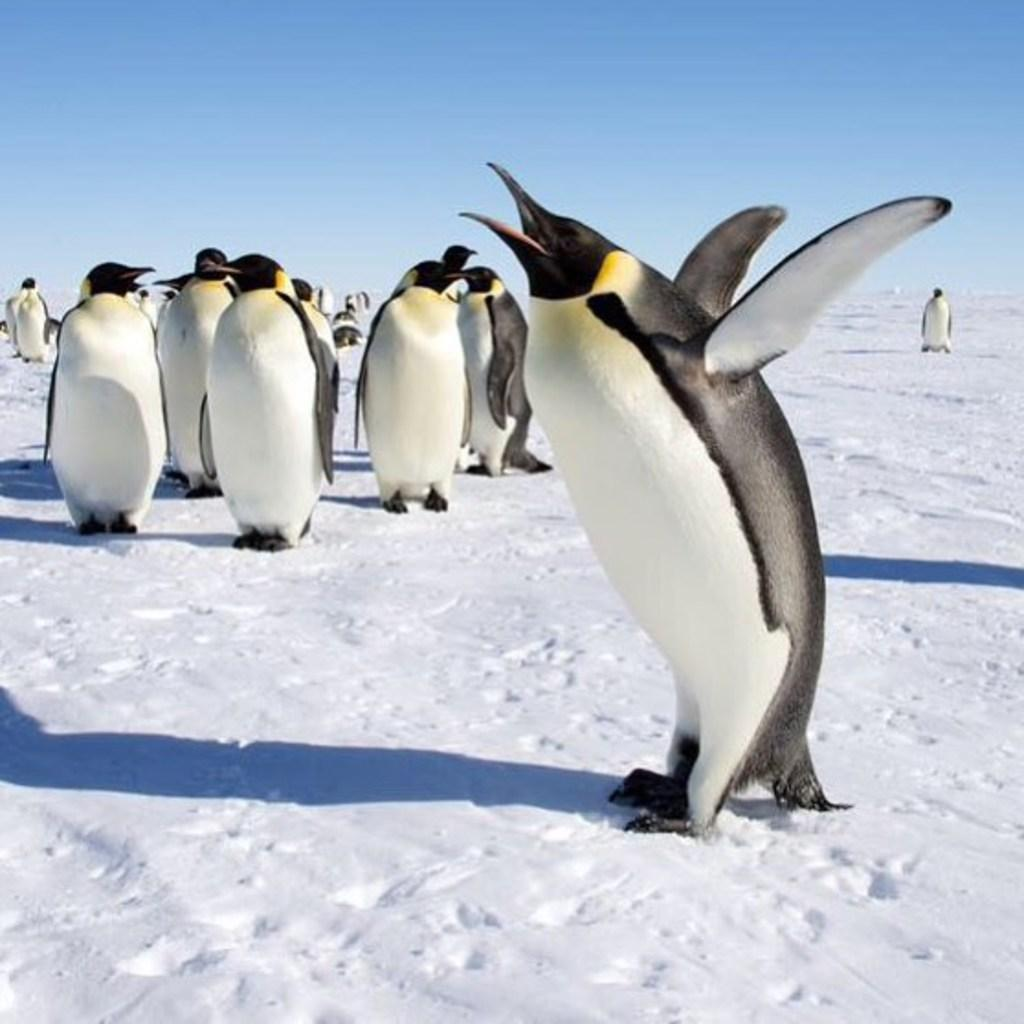What type of animals are present in the image? There are penguins in the image. What part of the natural environment is visible in the image? The sky is visible at the top of the image. How many chairs are visible in the image? There are no chairs present in the image. What type of canvas is being used by the penguins in the image? There is no canvas present in the image, and the penguins are not using any canvas. 